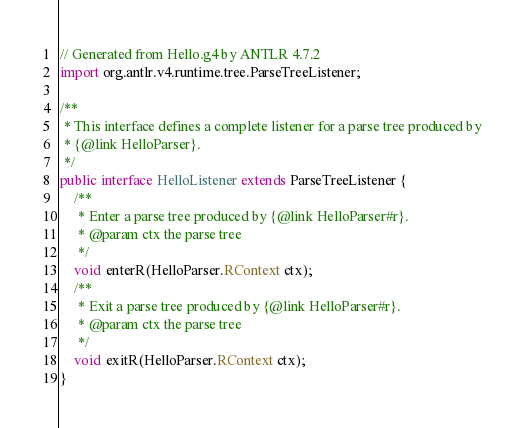Convert code to text. <code><loc_0><loc_0><loc_500><loc_500><_Java_>// Generated from Hello.g4 by ANTLR 4.7.2
import org.antlr.v4.runtime.tree.ParseTreeListener;

/**
 * This interface defines a complete listener for a parse tree produced by
 * {@link HelloParser}.
 */
public interface HelloListener extends ParseTreeListener {
	/**
	 * Enter a parse tree produced by {@link HelloParser#r}.
	 * @param ctx the parse tree
	 */
	void enterR(HelloParser.RContext ctx);
	/**
	 * Exit a parse tree produced by {@link HelloParser#r}.
	 * @param ctx the parse tree
	 */
	void exitR(HelloParser.RContext ctx);
}</code> 